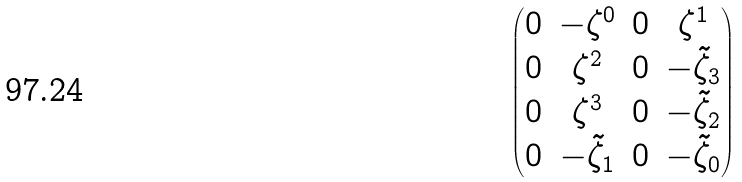Convert formula to latex. <formula><loc_0><loc_0><loc_500><loc_500>\begin{pmatrix} 0 & - { \zeta } ^ { 0 } & 0 & { \zeta } ^ { 1 } \\ 0 & { \zeta } ^ { 2 } & 0 & - \tilde { \zeta } _ { 3 } \\ 0 & { \zeta } ^ { 3 } & 0 & - \tilde { \zeta } _ { 2 } \\ 0 & - \tilde { \zeta } _ { 1 } & 0 & - \tilde { \zeta } _ { 0 } \end{pmatrix}</formula> 